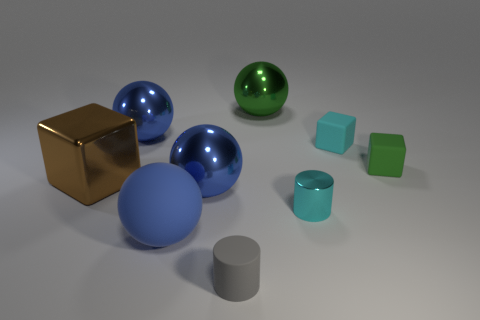Imagine these objects are part of a child's playset. How could they be used in play? In a child's playset, these objects could serve as pieces for creative and educational play. The spheres might be planets or balls to roll around, the cube could be a building block or a treasure chest, and the cylinders might serve as tree trunks or posts to build structures or create imaginary landscapes. The varying sizes and colors encourage sorting, stacking, and color identification activities, fostering both imaginative play and cognitive development. 